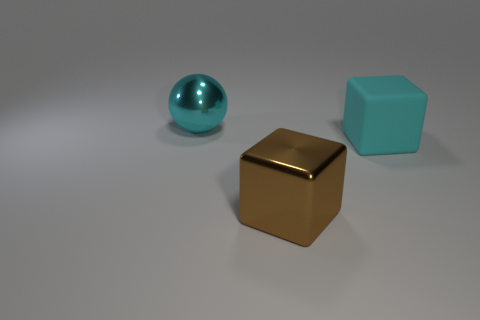Add 1 yellow metallic balls. How many objects exist? 4 Subtract all blocks. How many objects are left? 1 Add 2 large cyan metallic spheres. How many large cyan metallic spheres exist? 3 Subtract 1 cyan balls. How many objects are left? 2 Subtract all large brown things. Subtract all big cyan balls. How many objects are left? 1 Add 1 brown shiny objects. How many brown shiny objects are left? 2 